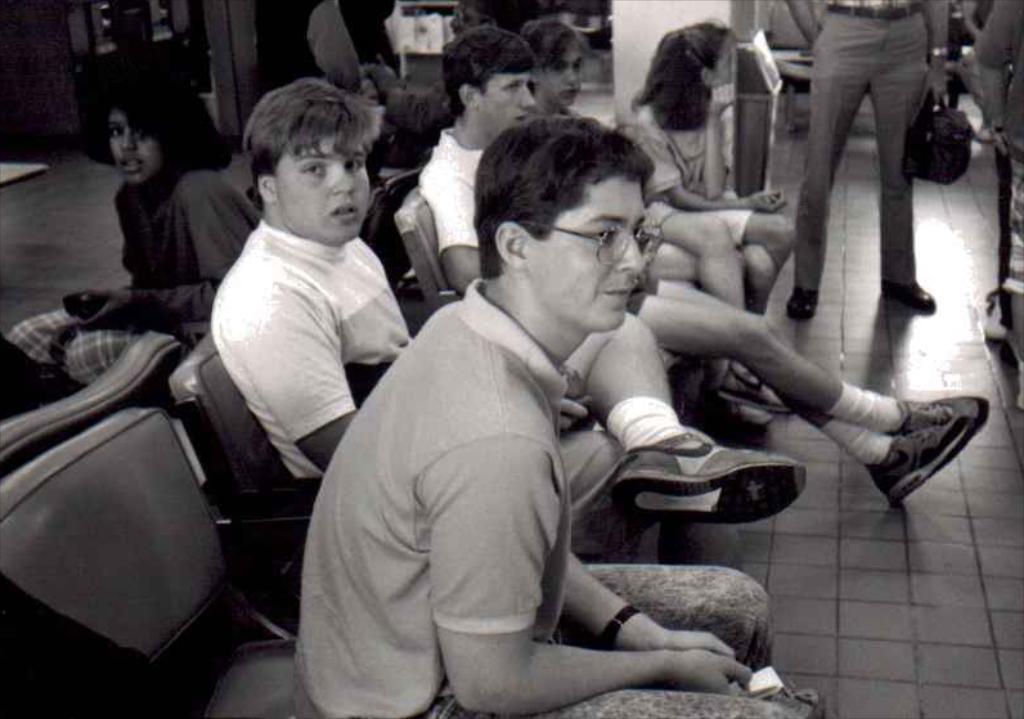In one or two sentences, can you explain what this image depicts? This is the black and white image where we can see these people are sitting on chairs and these people are walking on the floor. 